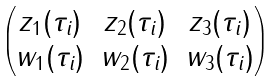Convert formula to latex. <formula><loc_0><loc_0><loc_500><loc_500>\begin{pmatrix} z _ { 1 } ( \tau _ { i } ) & z _ { 2 } ( \tau _ { i } ) & z _ { 3 } ( \tau _ { i } ) \\ w _ { 1 } ( \tau _ { i } ) & w _ { 2 } ( \tau _ { i } ) & w _ { 3 } ( \tau _ { i } ) \end{pmatrix}</formula> 